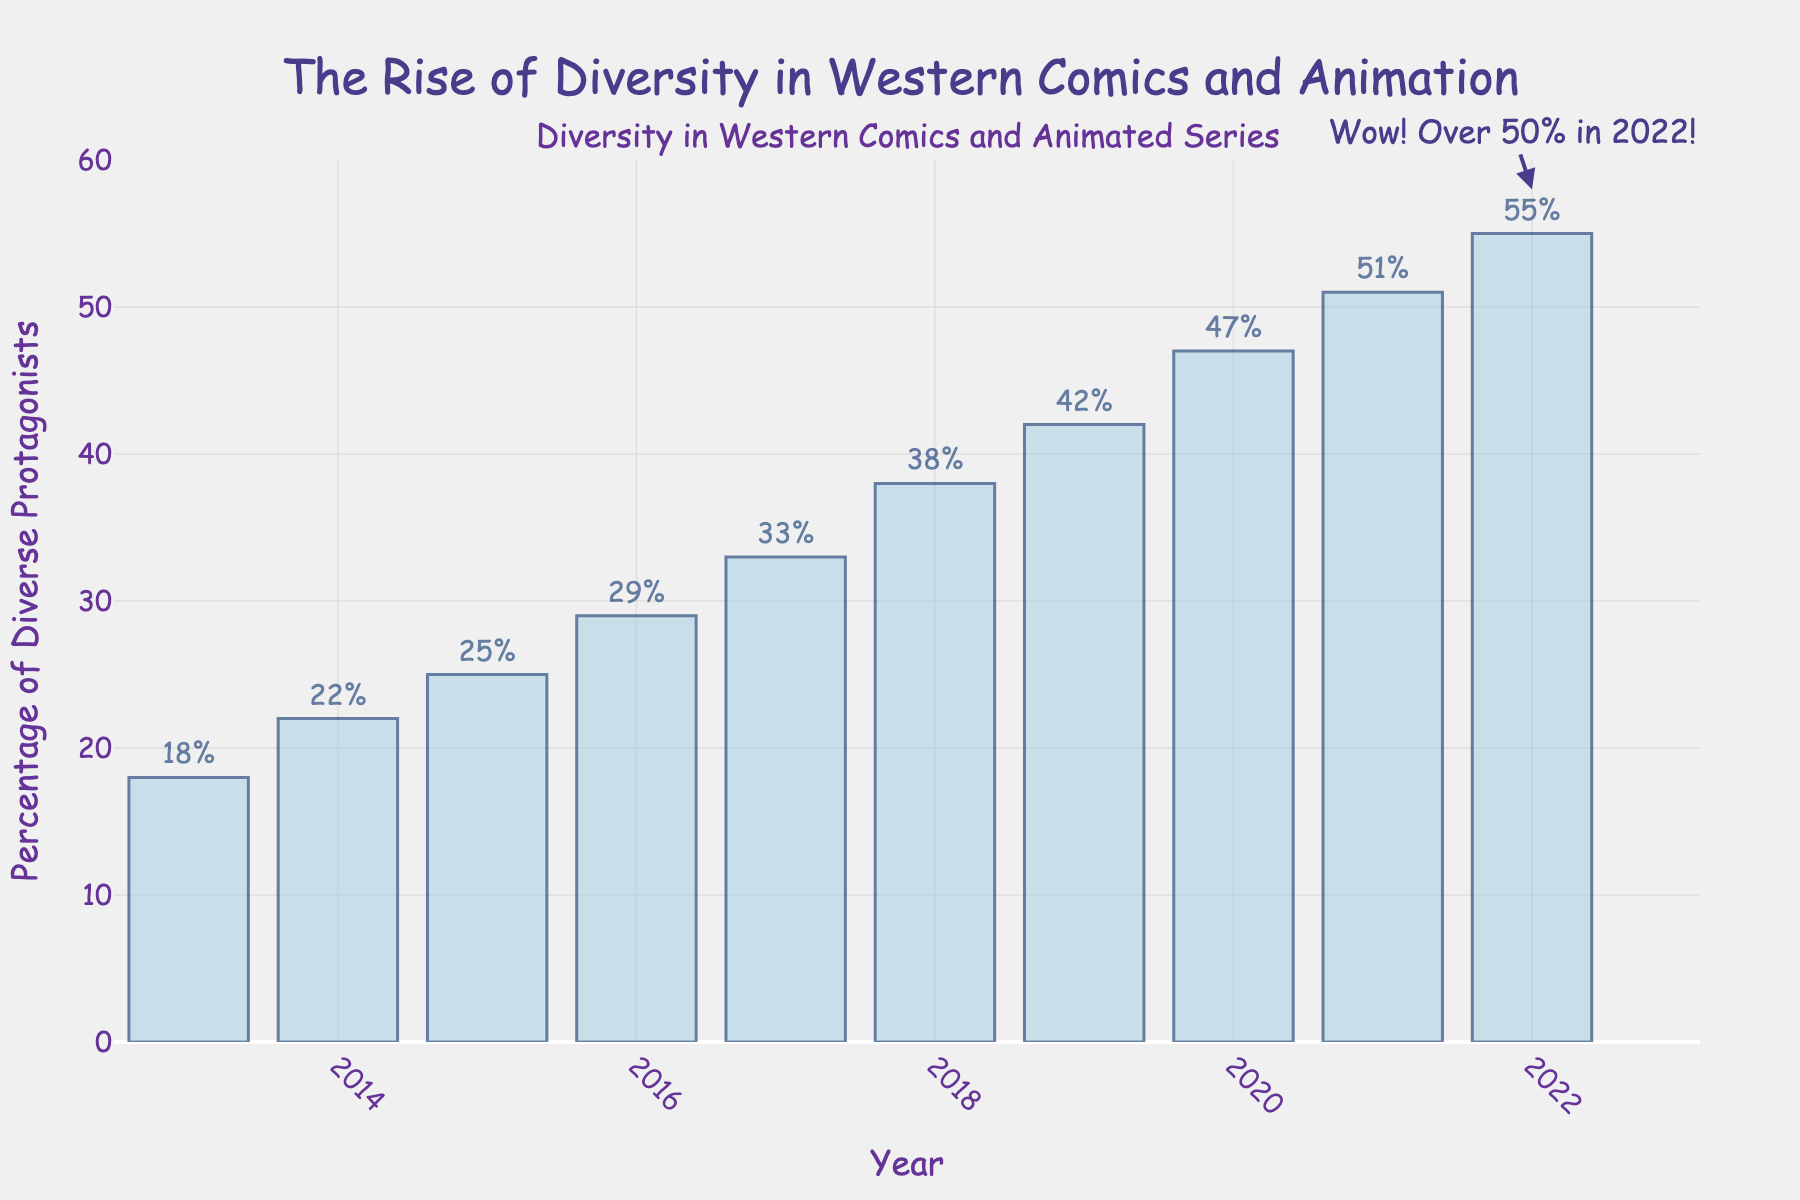What's the percentage of diverse protagonists in 2019? Look at the bar corresponding to 2019 and refer to its height and the text label. The label reads 42%.
Answer: 42% How much did the percentage of diverse protagonists increase from 2013 to 2022? Subtract the percentage in 2013 from the percentage in 2022: 55% (2022) - 18% (2013) = 37%.
Answer: 37% Which year saw the highest percentage of diverse protagonists? Identify the tallest bar in the chart, which is for the year 2022 with a percentage of 55%.
Answer: 2022 Between which consecutive years was the increase in the percentage of diverse protagonists the greatest? Calculate the difference for each consecutive year and identify the largest one. The largest increase is from 2020 to 2021 with an increase of 51% - 47% = 4%.
Answer: 2020-2021 What is the mean percentage of diverse protagonists from 2018 to 2022? Sum the percentages from 2018 to 2022 and divide by the number of years: (38% + 42% + 47% + 51% + 55%) / 5 = 46.6%.
Answer: 46.6% Did the percentage of diverse protagonists ever decrease between two consecutive years? Examine the height of the bars from year to year to see if there is any decline. In this chart, each year shows an increase compared to the previous year.
Answer: No Compare the percentage increase from 2013 to 2014 with the increase from 2016 to 2017. Which is greater? Calculate both differences and compare: 2014 - 2013 = 22% - 18% = 4% and 2017 - 2016 = 33% - 29% = 4%. Both increases are equal.
Answer: Both are equal What is the average annual increase in the percentage of diverse protagonists over the entire decade? Calculate the total increase from 2013 to 2022 and divide by the number of intervals (9): (55% - 18%) / 9 ≈ 4.111%.
Answer: ~4.111% How much did the percentage increase from 2015 to 2018? Sum the differences for each year from 2015 to 2018: (29% - 25%) + (33% - 29%) + (38% - 33%) = 4% + 4% + 5% = 13%.
Answer: 13% 